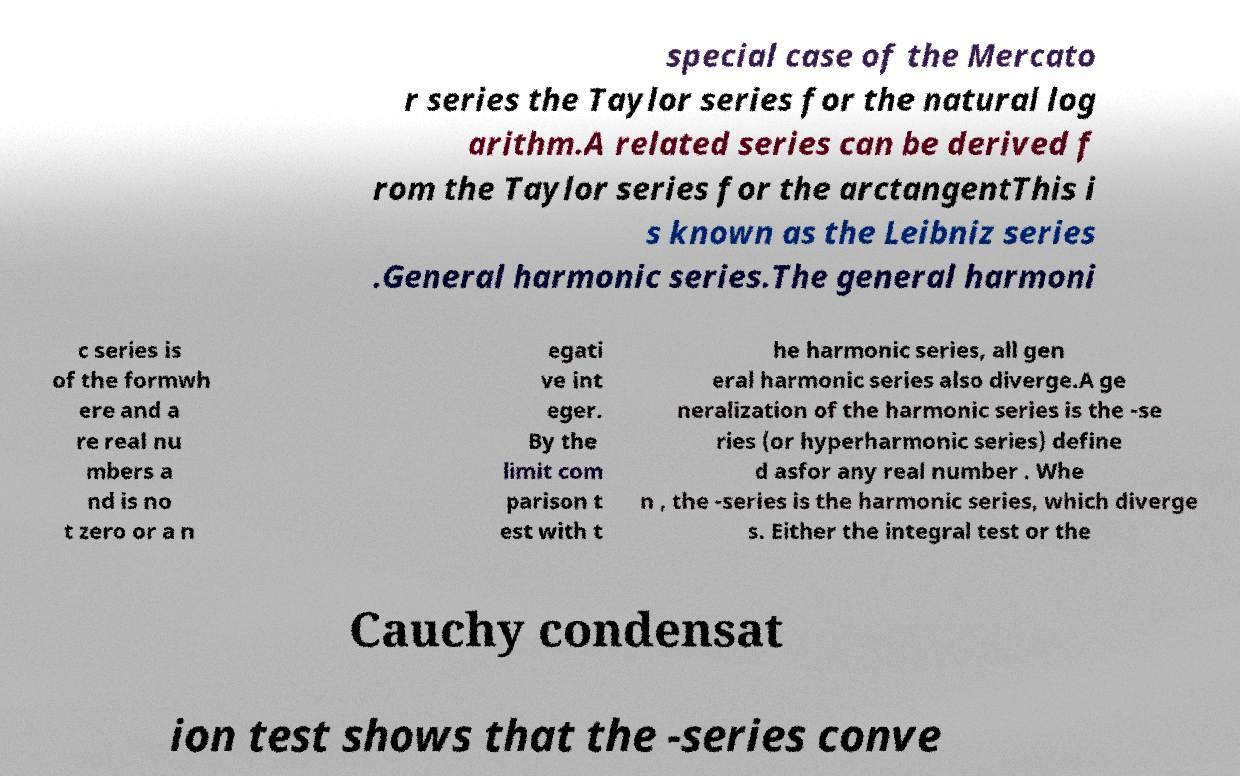For documentation purposes, I need the text within this image transcribed. Could you provide that? special case of the Mercato r series the Taylor series for the natural log arithm.A related series can be derived f rom the Taylor series for the arctangentThis i s known as the Leibniz series .General harmonic series.The general harmoni c series is of the formwh ere and a re real nu mbers a nd is no t zero or a n egati ve int eger. By the limit com parison t est with t he harmonic series, all gen eral harmonic series also diverge.A ge neralization of the harmonic series is the -se ries (or hyperharmonic series) define d asfor any real number . Whe n , the -series is the harmonic series, which diverge s. Either the integral test or the Cauchy condensat ion test shows that the -series conve 